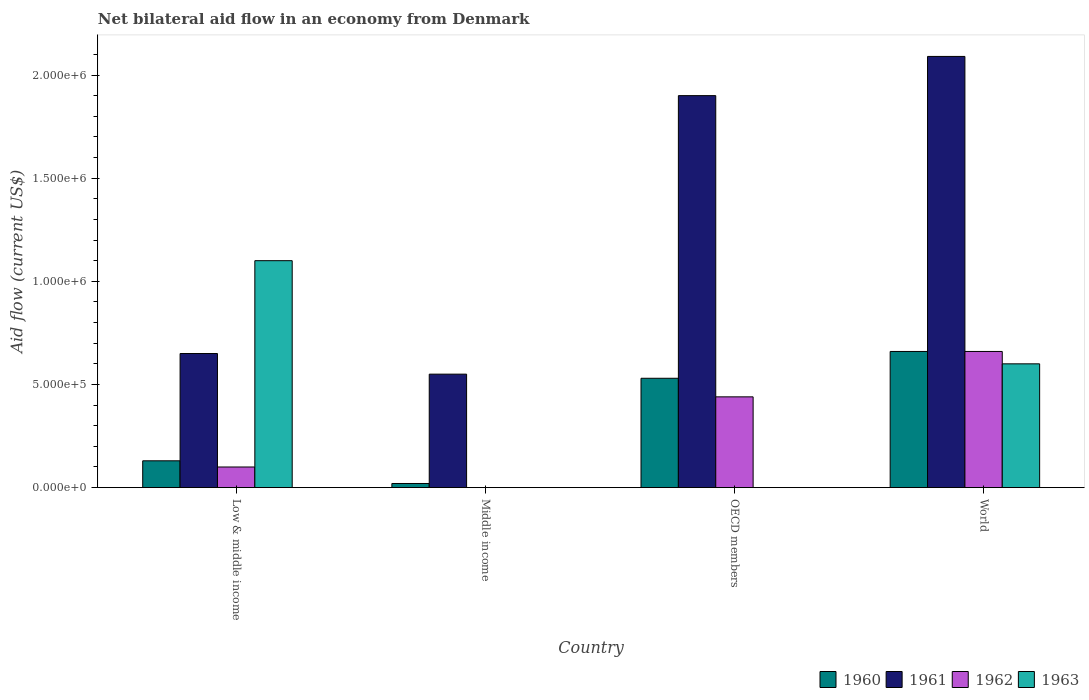How many groups of bars are there?
Make the answer very short. 4. Are the number of bars per tick equal to the number of legend labels?
Provide a succinct answer. No. Are the number of bars on each tick of the X-axis equal?
Ensure brevity in your answer.  No. How many bars are there on the 2nd tick from the left?
Keep it short and to the point. 2. What is the label of the 4th group of bars from the left?
Your response must be concise. World. Across all countries, what is the maximum net bilateral aid flow in 1962?
Make the answer very short. 6.60e+05. Across all countries, what is the minimum net bilateral aid flow in 1963?
Your response must be concise. 0. What is the total net bilateral aid flow in 1960 in the graph?
Provide a short and direct response. 1.34e+06. What is the difference between the net bilateral aid flow in 1962 in Low & middle income and that in OECD members?
Ensure brevity in your answer.  -3.40e+05. What is the difference between the net bilateral aid flow in 1960 in Low & middle income and the net bilateral aid flow in 1961 in Middle income?
Give a very brief answer. -4.20e+05. What is the difference between the net bilateral aid flow of/in 1961 and net bilateral aid flow of/in 1960 in World?
Make the answer very short. 1.43e+06. What is the ratio of the net bilateral aid flow in 1960 in Middle income to that in World?
Give a very brief answer. 0.03. Is the net bilateral aid flow in 1960 in Middle income less than that in World?
Give a very brief answer. Yes. What is the difference between the highest and the second highest net bilateral aid flow in 1962?
Provide a short and direct response. 5.60e+05. What is the difference between the highest and the lowest net bilateral aid flow in 1962?
Provide a succinct answer. 6.60e+05. In how many countries, is the net bilateral aid flow in 1962 greater than the average net bilateral aid flow in 1962 taken over all countries?
Your answer should be compact. 2. Is the sum of the net bilateral aid flow in 1961 in Low & middle income and OECD members greater than the maximum net bilateral aid flow in 1960 across all countries?
Offer a very short reply. Yes. Is it the case that in every country, the sum of the net bilateral aid flow in 1961 and net bilateral aid flow in 1963 is greater than the net bilateral aid flow in 1962?
Offer a terse response. Yes. How many countries are there in the graph?
Give a very brief answer. 4. Are the values on the major ticks of Y-axis written in scientific E-notation?
Keep it short and to the point. Yes. Does the graph contain grids?
Keep it short and to the point. No. Where does the legend appear in the graph?
Provide a succinct answer. Bottom right. How many legend labels are there?
Give a very brief answer. 4. What is the title of the graph?
Give a very brief answer. Net bilateral aid flow in an economy from Denmark. What is the Aid flow (current US$) in 1961 in Low & middle income?
Offer a very short reply. 6.50e+05. What is the Aid flow (current US$) in 1962 in Low & middle income?
Give a very brief answer. 1.00e+05. What is the Aid flow (current US$) of 1963 in Low & middle income?
Your answer should be compact. 1.10e+06. What is the Aid flow (current US$) of 1960 in Middle income?
Offer a very short reply. 2.00e+04. What is the Aid flow (current US$) in 1961 in Middle income?
Your answer should be compact. 5.50e+05. What is the Aid flow (current US$) in 1962 in Middle income?
Give a very brief answer. 0. What is the Aid flow (current US$) in 1963 in Middle income?
Keep it short and to the point. 0. What is the Aid flow (current US$) of 1960 in OECD members?
Ensure brevity in your answer.  5.30e+05. What is the Aid flow (current US$) in 1961 in OECD members?
Ensure brevity in your answer.  1.90e+06. What is the Aid flow (current US$) of 1962 in OECD members?
Ensure brevity in your answer.  4.40e+05. What is the Aid flow (current US$) of 1960 in World?
Your response must be concise. 6.60e+05. What is the Aid flow (current US$) of 1961 in World?
Offer a very short reply. 2.09e+06. What is the Aid flow (current US$) in 1962 in World?
Your answer should be very brief. 6.60e+05. Across all countries, what is the maximum Aid flow (current US$) of 1961?
Your response must be concise. 2.09e+06. Across all countries, what is the maximum Aid flow (current US$) in 1963?
Your answer should be compact. 1.10e+06. Across all countries, what is the minimum Aid flow (current US$) in 1961?
Provide a short and direct response. 5.50e+05. What is the total Aid flow (current US$) in 1960 in the graph?
Make the answer very short. 1.34e+06. What is the total Aid flow (current US$) of 1961 in the graph?
Provide a short and direct response. 5.19e+06. What is the total Aid flow (current US$) in 1962 in the graph?
Provide a short and direct response. 1.20e+06. What is the total Aid flow (current US$) in 1963 in the graph?
Provide a succinct answer. 1.70e+06. What is the difference between the Aid flow (current US$) in 1960 in Low & middle income and that in Middle income?
Your answer should be compact. 1.10e+05. What is the difference between the Aid flow (current US$) in 1961 in Low & middle income and that in Middle income?
Offer a terse response. 1.00e+05. What is the difference between the Aid flow (current US$) in 1960 in Low & middle income and that in OECD members?
Your answer should be very brief. -4.00e+05. What is the difference between the Aid flow (current US$) of 1961 in Low & middle income and that in OECD members?
Your response must be concise. -1.25e+06. What is the difference between the Aid flow (current US$) of 1962 in Low & middle income and that in OECD members?
Provide a succinct answer. -3.40e+05. What is the difference between the Aid flow (current US$) of 1960 in Low & middle income and that in World?
Offer a very short reply. -5.30e+05. What is the difference between the Aid flow (current US$) in 1961 in Low & middle income and that in World?
Give a very brief answer. -1.44e+06. What is the difference between the Aid flow (current US$) in 1962 in Low & middle income and that in World?
Your response must be concise. -5.60e+05. What is the difference between the Aid flow (current US$) in 1963 in Low & middle income and that in World?
Provide a succinct answer. 5.00e+05. What is the difference between the Aid flow (current US$) in 1960 in Middle income and that in OECD members?
Offer a very short reply. -5.10e+05. What is the difference between the Aid flow (current US$) of 1961 in Middle income and that in OECD members?
Keep it short and to the point. -1.35e+06. What is the difference between the Aid flow (current US$) in 1960 in Middle income and that in World?
Your response must be concise. -6.40e+05. What is the difference between the Aid flow (current US$) in 1961 in Middle income and that in World?
Provide a succinct answer. -1.54e+06. What is the difference between the Aid flow (current US$) of 1961 in OECD members and that in World?
Provide a short and direct response. -1.90e+05. What is the difference between the Aid flow (current US$) of 1962 in OECD members and that in World?
Make the answer very short. -2.20e+05. What is the difference between the Aid flow (current US$) in 1960 in Low & middle income and the Aid flow (current US$) in 1961 in Middle income?
Offer a very short reply. -4.20e+05. What is the difference between the Aid flow (current US$) of 1960 in Low & middle income and the Aid flow (current US$) of 1961 in OECD members?
Your response must be concise. -1.77e+06. What is the difference between the Aid flow (current US$) in 1960 in Low & middle income and the Aid flow (current US$) in 1962 in OECD members?
Provide a succinct answer. -3.10e+05. What is the difference between the Aid flow (current US$) in 1960 in Low & middle income and the Aid flow (current US$) in 1961 in World?
Provide a short and direct response. -1.96e+06. What is the difference between the Aid flow (current US$) in 1960 in Low & middle income and the Aid flow (current US$) in 1962 in World?
Provide a succinct answer. -5.30e+05. What is the difference between the Aid flow (current US$) in 1960 in Low & middle income and the Aid flow (current US$) in 1963 in World?
Ensure brevity in your answer.  -4.70e+05. What is the difference between the Aid flow (current US$) in 1961 in Low & middle income and the Aid flow (current US$) in 1962 in World?
Ensure brevity in your answer.  -10000. What is the difference between the Aid flow (current US$) of 1961 in Low & middle income and the Aid flow (current US$) of 1963 in World?
Ensure brevity in your answer.  5.00e+04. What is the difference between the Aid flow (current US$) in 1962 in Low & middle income and the Aid flow (current US$) in 1963 in World?
Make the answer very short. -5.00e+05. What is the difference between the Aid flow (current US$) in 1960 in Middle income and the Aid flow (current US$) in 1961 in OECD members?
Make the answer very short. -1.88e+06. What is the difference between the Aid flow (current US$) of 1960 in Middle income and the Aid flow (current US$) of 1962 in OECD members?
Your answer should be compact. -4.20e+05. What is the difference between the Aid flow (current US$) of 1961 in Middle income and the Aid flow (current US$) of 1962 in OECD members?
Give a very brief answer. 1.10e+05. What is the difference between the Aid flow (current US$) of 1960 in Middle income and the Aid flow (current US$) of 1961 in World?
Give a very brief answer. -2.07e+06. What is the difference between the Aid flow (current US$) of 1960 in Middle income and the Aid flow (current US$) of 1962 in World?
Ensure brevity in your answer.  -6.40e+05. What is the difference between the Aid flow (current US$) of 1960 in Middle income and the Aid flow (current US$) of 1963 in World?
Provide a succinct answer. -5.80e+05. What is the difference between the Aid flow (current US$) in 1961 in Middle income and the Aid flow (current US$) in 1963 in World?
Ensure brevity in your answer.  -5.00e+04. What is the difference between the Aid flow (current US$) in 1960 in OECD members and the Aid flow (current US$) in 1961 in World?
Provide a succinct answer. -1.56e+06. What is the difference between the Aid flow (current US$) in 1961 in OECD members and the Aid flow (current US$) in 1962 in World?
Offer a terse response. 1.24e+06. What is the difference between the Aid flow (current US$) in 1961 in OECD members and the Aid flow (current US$) in 1963 in World?
Make the answer very short. 1.30e+06. What is the average Aid flow (current US$) in 1960 per country?
Your answer should be compact. 3.35e+05. What is the average Aid flow (current US$) of 1961 per country?
Make the answer very short. 1.30e+06. What is the average Aid flow (current US$) of 1962 per country?
Provide a succinct answer. 3.00e+05. What is the average Aid flow (current US$) in 1963 per country?
Ensure brevity in your answer.  4.25e+05. What is the difference between the Aid flow (current US$) in 1960 and Aid flow (current US$) in 1961 in Low & middle income?
Offer a terse response. -5.20e+05. What is the difference between the Aid flow (current US$) in 1960 and Aid flow (current US$) in 1962 in Low & middle income?
Give a very brief answer. 3.00e+04. What is the difference between the Aid flow (current US$) of 1960 and Aid flow (current US$) of 1963 in Low & middle income?
Provide a short and direct response. -9.70e+05. What is the difference between the Aid flow (current US$) in 1961 and Aid flow (current US$) in 1962 in Low & middle income?
Your answer should be compact. 5.50e+05. What is the difference between the Aid flow (current US$) of 1961 and Aid flow (current US$) of 1963 in Low & middle income?
Provide a short and direct response. -4.50e+05. What is the difference between the Aid flow (current US$) of 1962 and Aid flow (current US$) of 1963 in Low & middle income?
Give a very brief answer. -1.00e+06. What is the difference between the Aid flow (current US$) in 1960 and Aid flow (current US$) in 1961 in Middle income?
Provide a short and direct response. -5.30e+05. What is the difference between the Aid flow (current US$) in 1960 and Aid flow (current US$) in 1961 in OECD members?
Ensure brevity in your answer.  -1.37e+06. What is the difference between the Aid flow (current US$) in 1960 and Aid flow (current US$) in 1962 in OECD members?
Ensure brevity in your answer.  9.00e+04. What is the difference between the Aid flow (current US$) in 1961 and Aid flow (current US$) in 1962 in OECD members?
Offer a terse response. 1.46e+06. What is the difference between the Aid flow (current US$) of 1960 and Aid flow (current US$) of 1961 in World?
Your response must be concise. -1.43e+06. What is the difference between the Aid flow (current US$) of 1960 and Aid flow (current US$) of 1963 in World?
Offer a terse response. 6.00e+04. What is the difference between the Aid flow (current US$) of 1961 and Aid flow (current US$) of 1962 in World?
Make the answer very short. 1.43e+06. What is the difference between the Aid flow (current US$) in 1961 and Aid flow (current US$) in 1963 in World?
Offer a terse response. 1.49e+06. What is the ratio of the Aid flow (current US$) in 1961 in Low & middle income to that in Middle income?
Your answer should be compact. 1.18. What is the ratio of the Aid flow (current US$) of 1960 in Low & middle income to that in OECD members?
Offer a very short reply. 0.25. What is the ratio of the Aid flow (current US$) in 1961 in Low & middle income to that in OECD members?
Give a very brief answer. 0.34. What is the ratio of the Aid flow (current US$) of 1962 in Low & middle income to that in OECD members?
Provide a short and direct response. 0.23. What is the ratio of the Aid flow (current US$) of 1960 in Low & middle income to that in World?
Provide a succinct answer. 0.2. What is the ratio of the Aid flow (current US$) in 1961 in Low & middle income to that in World?
Keep it short and to the point. 0.31. What is the ratio of the Aid flow (current US$) in 1962 in Low & middle income to that in World?
Your answer should be very brief. 0.15. What is the ratio of the Aid flow (current US$) in 1963 in Low & middle income to that in World?
Offer a terse response. 1.83. What is the ratio of the Aid flow (current US$) of 1960 in Middle income to that in OECD members?
Provide a succinct answer. 0.04. What is the ratio of the Aid flow (current US$) in 1961 in Middle income to that in OECD members?
Keep it short and to the point. 0.29. What is the ratio of the Aid flow (current US$) in 1960 in Middle income to that in World?
Your answer should be compact. 0.03. What is the ratio of the Aid flow (current US$) of 1961 in Middle income to that in World?
Give a very brief answer. 0.26. What is the ratio of the Aid flow (current US$) in 1960 in OECD members to that in World?
Provide a short and direct response. 0.8. What is the difference between the highest and the lowest Aid flow (current US$) in 1960?
Your answer should be very brief. 6.40e+05. What is the difference between the highest and the lowest Aid flow (current US$) in 1961?
Offer a very short reply. 1.54e+06. What is the difference between the highest and the lowest Aid flow (current US$) of 1963?
Your response must be concise. 1.10e+06. 